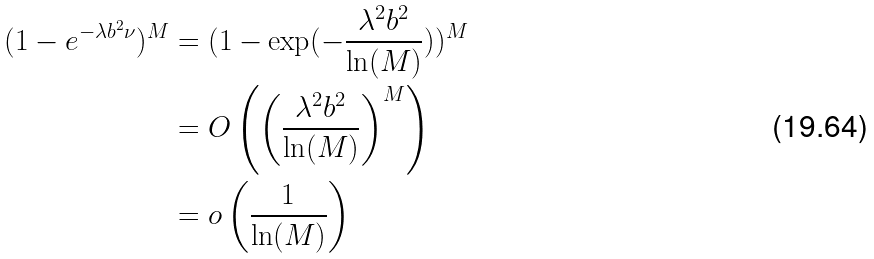<formula> <loc_0><loc_0><loc_500><loc_500>( 1 - e ^ { - \lambda b ^ { 2 } \nu } ) ^ { M } & = ( 1 - \exp ( - \frac { \lambda ^ { 2 } b ^ { 2 } } { \ln ( M ) } ) ) ^ { M } \\ & = O \left ( \left ( \frac { \lambda ^ { 2 } b ^ { 2 } } { \ln ( M ) } \right ) ^ { M } \right ) \\ & = o \left ( \frac { 1 } { \ln ( M ) } \right )</formula> 